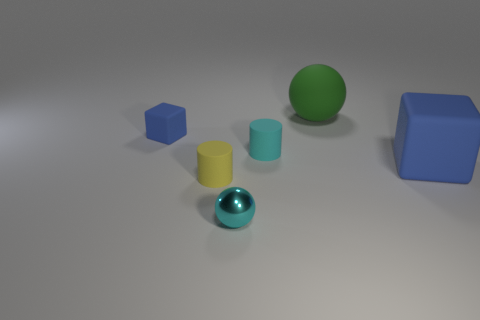There is a large rubber thing behind the small blue rubber object; is its shape the same as the large blue rubber object?
Give a very brief answer. No. Is the shape of the tiny yellow matte thing the same as the cyan rubber object?
Keep it short and to the point. Yes. Is there a small yellow matte thing of the same shape as the green thing?
Provide a short and direct response. No. What is the shape of the blue rubber thing that is left of the tiny cylinder that is on the left side of the shiny sphere?
Provide a succinct answer. Cube. There is a small rubber cylinder left of the cyan ball; what color is it?
Your answer should be compact. Yellow. The other blue object that is the same material as the large blue object is what size?
Ensure brevity in your answer.  Small. There is another matte thing that is the same shape as the tiny yellow object; what is its size?
Provide a succinct answer. Small. Is there a tiny thing?
Offer a terse response. Yes. How many objects are either blue rubber blocks that are on the right side of the small blue cube or tiny blue rubber things?
Ensure brevity in your answer.  2. There is a blue object that is the same size as the cyan shiny ball; what material is it?
Make the answer very short. Rubber. 